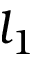Convert formula to latex. <formula><loc_0><loc_0><loc_500><loc_500>l _ { 1 }</formula> 